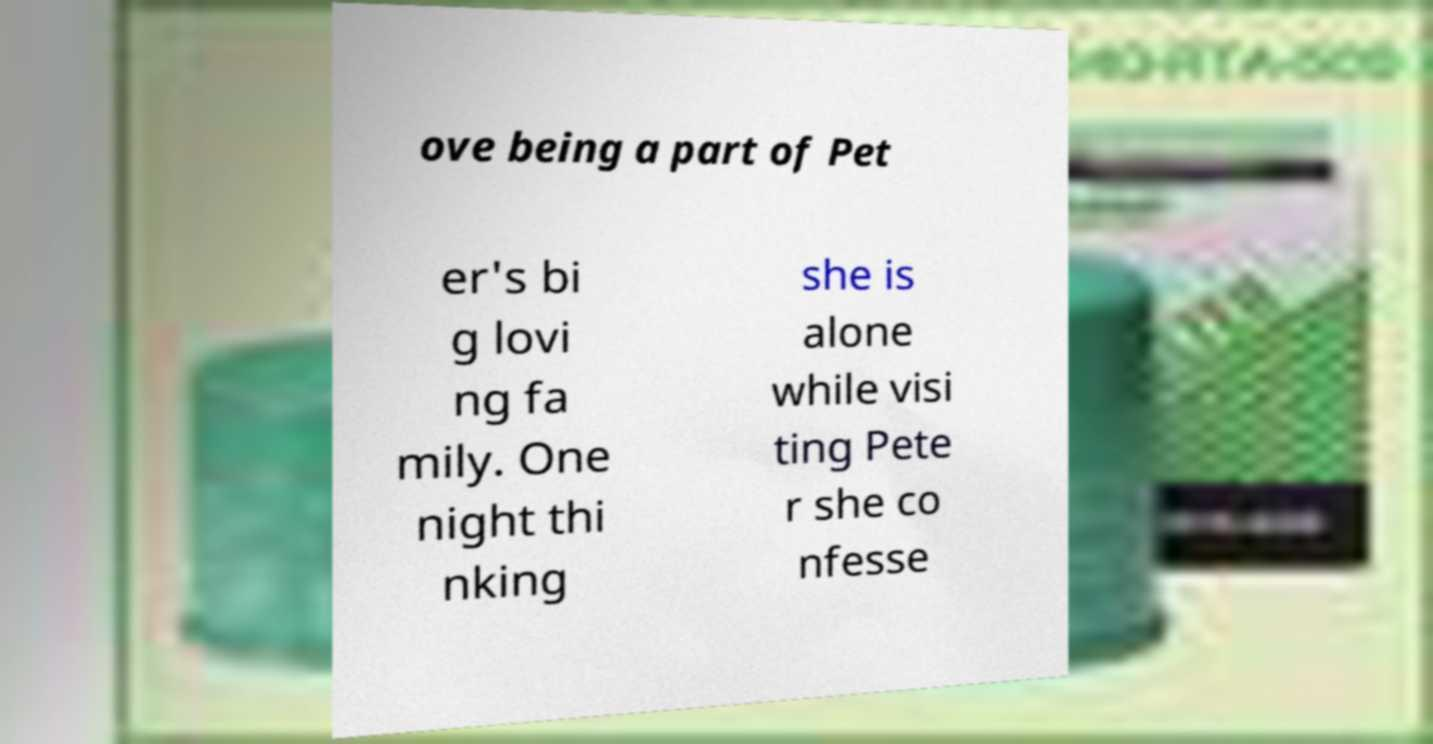Please identify and transcribe the text found in this image. ove being a part of Pet er's bi g lovi ng fa mily. One night thi nking she is alone while visi ting Pete r she co nfesse 